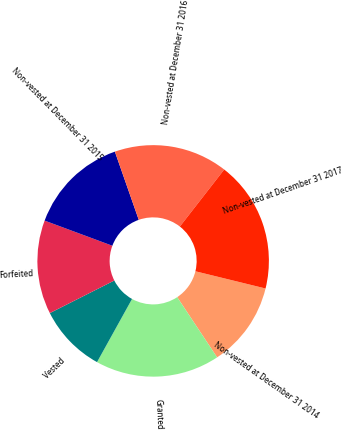<chart> <loc_0><loc_0><loc_500><loc_500><pie_chart><fcel>Non-vested at December 31 2014<fcel>Granted<fcel>Vested<fcel>Forfeited<fcel>Non-vested at December 31 2015<fcel>Non-vested at December 31 2016<fcel>Non-vested at December 31 2017<nl><fcel>11.85%<fcel>17.37%<fcel>9.5%<fcel>13.1%<fcel>13.98%<fcel>15.88%<fcel>18.31%<nl></chart> 